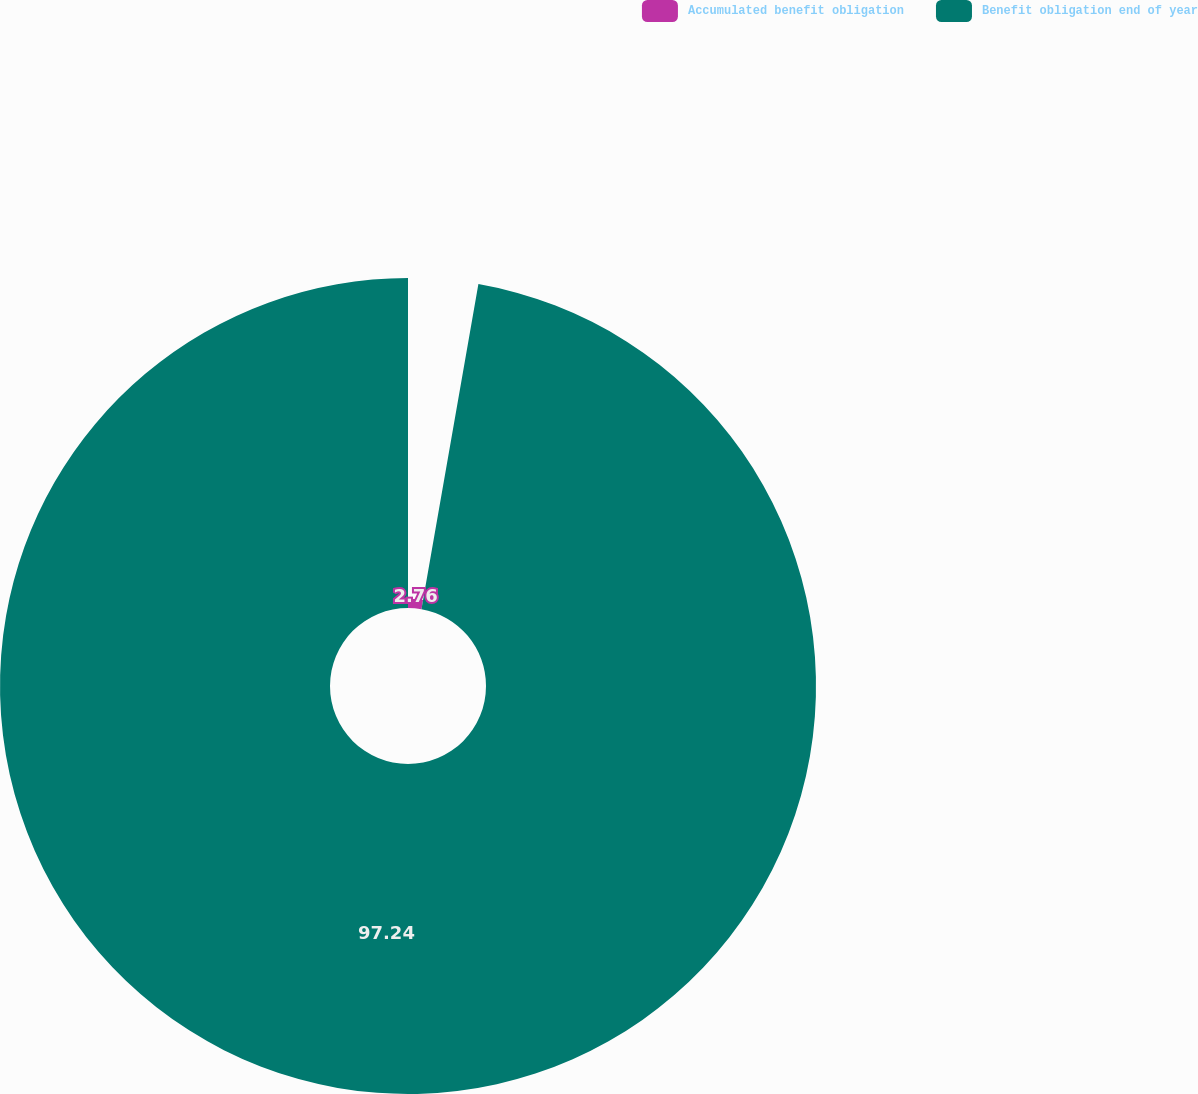<chart> <loc_0><loc_0><loc_500><loc_500><pie_chart><fcel>Accumulated benefit obligation<fcel>Benefit obligation end of year<nl><fcel>2.76%<fcel>97.24%<nl></chart> 